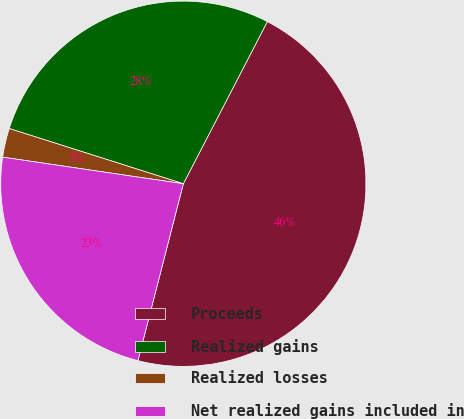<chart> <loc_0><loc_0><loc_500><loc_500><pie_chart><fcel>Proceeds<fcel>Realized gains<fcel>Realized losses<fcel>Net realized gains included in<nl><fcel>46.39%<fcel>27.72%<fcel>2.56%<fcel>23.33%<nl></chart> 